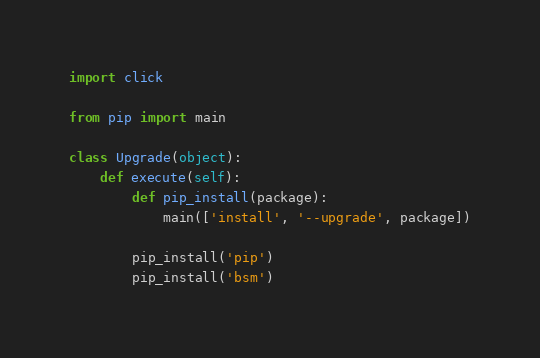<code> <loc_0><loc_0><loc_500><loc_500><_Python_>import click

from pip import main

class Upgrade(object):
    def execute(self):
        def pip_install(package):
            main(['install', '--upgrade', package])

        pip_install('pip')
        pip_install('bsm')
</code> 